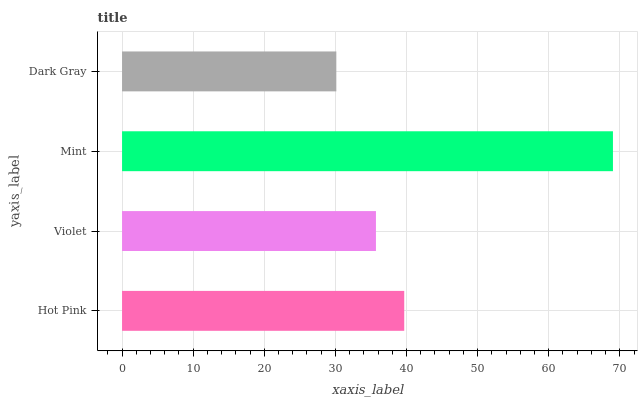Is Dark Gray the minimum?
Answer yes or no. Yes. Is Mint the maximum?
Answer yes or no. Yes. Is Violet the minimum?
Answer yes or no. No. Is Violet the maximum?
Answer yes or no. No. Is Hot Pink greater than Violet?
Answer yes or no. Yes. Is Violet less than Hot Pink?
Answer yes or no. Yes. Is Violet greater than Hot Pink?
Answer yes or no. No. Is Hot Pink less than Violet?
Answer yes or no. No. Is Hot Pink the high median?
Answer yes or no. Yes. Is Violet the low median?
Answer yes or no. Yes. Is Mint the high median?
Answer yes or no. No. Is Mint the low median?
Answer yes or no. No. 